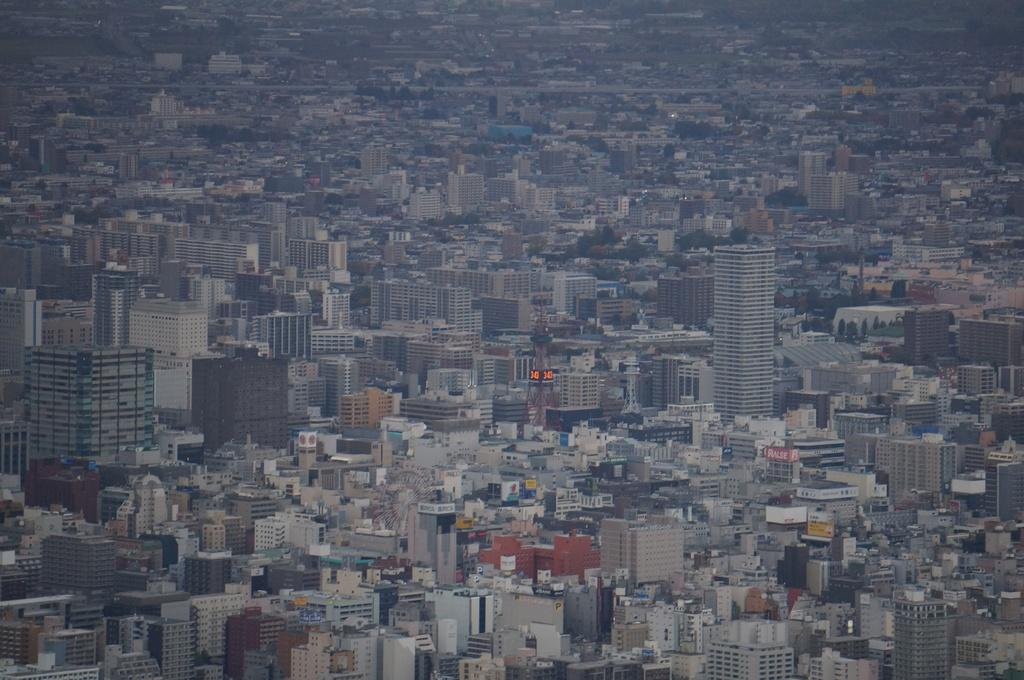What type of view is shown in the image? The image shows an aerial view of a city. What can be observed in the city from this view? There are many buildings in the city, including tower buildings with multiple floors. What type of stage can be seen in the image? There is no stage present in the image; it shows an aerial view of a city with buildings and towers. How does the pollution affect the city in the image? The image does not show any pollution, so it cannot be determined how it affects the city. 